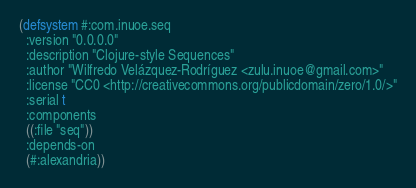<code> <loc_0><loc_0><loc_500><loc_500><_Lisp_>(defsystem #:com.inuoe.seq
  :version "0.0.0.0"
  :description "Clojure-style Sequences"
  :author "Wilfredo Velázquez-Rodríguez <zulu.inuoe@gmail.com>"
  :license "CC0 <http://creativecommons.org/publicdomain/zero/1.0/>"
  :serial t
  :components
  ((:file "seq"))
  :depends-on
  (#:alexandria))
</code> 